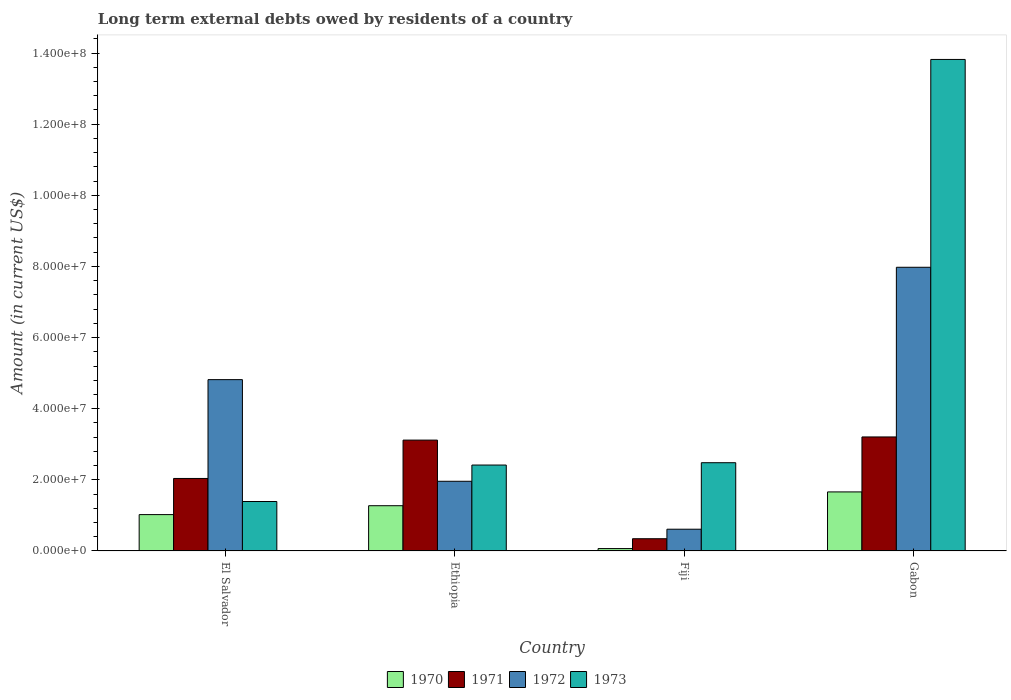How many different coloured bars are there?
Your response must be concise. 4. How many groups of bars are there?
Offer a very short reply. 4. Are the number of bars per tick equal to the number of legend labels?
Give a very brief answer. Yes. What is the label of the 1st group of bars from the left?
Provide a short and direct response. El Salvador. What is the amount of long-term external debts owed by residents in 1973 in El Salvador?
Provide a succinct answer. 1.39e+07. Across all countries, what is the maximum amount of long-term external debts owed by residents in 1973?
Make the answer very short. 1.38e+08. Across all countries, what is the minimum amount of long-term external debts owed by residents in 1972?
Provide a succinct answer. 6.12e+06. In which country was the amount of long-term external debts owed by residents in 1972 maximum?
Offer a terse response. Gabon. In which country was the amount of long-term external debts owed by residents in 1972 minimum?
Your answer should be compact. Fiji. What is the total amount of long-term external debts owed by residents in 1970 in the graph?
Offer a very short reply. 4.02e+07. What is the difference between the amount of long-term external debts owed by residents in 1973 in El Salvador and that in Fiji?
Give a very brief answer. -1.09e+07. What is the difference between the amount of long-term external debts owed by residents in 1971 in El Salvador and the amount of long-term external debts owed by residents in 1970 in Fiji?
Your answer should be very brief. 1.97e+07. What is the average amount of long-term external debts owed by residents in 1971 per country?
Make the answer very short. 2.18e+07. What is the difference between the amount of long-term external debts owed by residents of/in 1973 and amount of long-term external debts owed by residents of/in 1972 in Ethiopia?
Your answer should be compact. 4.56e+06. What is the ratio of the amount of long-term external debts owed by residents in 1970 in El Salvador to that in Fiji?
Offer a terse response. 15.1. Is the difference between the amount of long-term external debts owed by residents in 1973 in Fiji and Gabon greater than the difference between the amount of long-term external debts owed by residents in 1972 in Fiji and Gabon?
Keep it short and to the point. No. What is the difference between the highest and the second highest amount of long-term external debts owed by residents in 1971?
Make the answer very short. 8.88e+05. What is the difference between the highest and the lowest amount of long-term external debts owed by residents in 1971?
Provide a succinct answer. 2.86e+07. Is the sum of the amount of long-term external debts owed by residents in 1973 in Ethiopia and Fiji greater than the maximum amount of long-term external debts owed by residents in 1970 across all countries?
Ensure brevity in your answer.  Yes. What does the 3rd bar from the right in Gabon represents?
Keep it short and to the point. 1971. How many bars are there?
Ensure brevity in your answer.  16. Are all the bars in the graph horizontal?
Offer a very short reply. No. What is the difference between two consecutive major ticks on the Y-axis?
Make the answer very short. 2.00e+07. Does the graph contain any zero values?
Your answer should be very brief. No. Where does the legend appear in the graph?
Make the answer very short. Bottom center. How are the legend labels stacked?
Your answer should be compact. Horizontal. What is the title of the graph?
Your response must be concise. Long term external debts owed by residents of a country. Does "1993" appear as one of the legend labels in the graph?
Give a very brief answer. No. What is the Amount (in current US$) of 1970 in El Salvador?
Your answer should be very brief. 1.02e+07. What is the Amount (in current US$) of 1971 in El Salvador?
Give a very brief answer. 2.04e+07. What is the Amount (in current US$) of 1972 in El Salvador?
Provide a short and direct response. 4.82e+07. What is the Amount (in current US$) in 1973 in El Salvador?
Your answer should be very brief. 1.39e+07. What is the Amount (in current US$) in 1970 in Ethiopia?
Your answer should be very brief. 1.27e+07. What is the Amount (in current US$) of 1971 in Ethiopia?
Offer a terse response. 3.12e+07. What is the Amount (in current US$) of 1972 in Ethiopia?
Your answer should be very brief. 1.96e+07. What is the Amount (in current US$) in 1973 in Ethiopia?
Offer a very short reply. 2.42e+07. What is the Amount (in current US$) of 1970 in Fiji?
Provide a short and direct response. 6.77e+05. What is the Amount (in current US$) in 1971 in Fiji?
Provide a succinct answer. 3.45e+06. What is the Amount (in current US$) of 1972 in Fiji?
Your answer should be very brief. 6.12e+06. What is the Amount (in current US$) in 1973 in Fiji?
Make the answer very short. 2.48e+07. What is the Amount (in current US$) in 1970 in Gabon?
Provide a short and direct response. 1.66e+07. What is the Amount (in current US$) in 1971 in Gabon?
Keep it short and to the point. 3.21e+07. What is the Amount (in current US$) of 1972 in Gabon?
Give a very brief answer. 7.98e+07. What is the Amount (in current US$) in 1973 in Gabon?
Keep it short and to the point. 1.38e+08. Across all countries, what is the maximum Amount (in current US$) of 1970?
Keep it short and to the point. 1.66e+07. Across all countries, what is the maximum Amount (in current US$) of 1971?
Give a very brief answer. 3.21e+07. Across all countries, what is the maximum Amount (in current US$) in 1972?
Provide a short and direct response. 7.98e+07. Across all countries, what is the maximum Amount (in current US$) in 1973?
Ensure brevity in your answer.  1.38e+08. Across all countries, what is the minimum Amount (in current US$) in 1970?
Keep it short and to the point. 6.77e+05. Across all countries, what is the minimum Amount (in current US$) in 1971?
Your answer should be compact. 3.45e+06. Across all countries, what is the minimum Amount (in current US$) in 1972?
Ensure brevity in your answer.  6.12e+06. Across all countries, what is the minimum Amount (in current US$) of 1973?
Offer a terse response. 1.39e+07. What is the total Amount (in current US$) in 1970 in the graph?
Give a very brief answer. 4.02e+07. What is the total Amount (in current US$) in 1971 in the graph?
Your response must be concise. 8.71e+07. What is the total Amount (in current US$) of 1972 in the graph?
Make the answer very short. 1.54e+08. What is the total Amount (in current US$) of 1973 in the graph?
Ensure brevity in your answer.  2.01e+08. What is the difference between the Amount (in current US$) in 1970 in El Salvador and that in Ethiopia?
Your answer should be very brief. -2.50e+06. What is the difference between the Amount (in current US$) in 1971 in El Salvador and that in Ethiopia?
Offer a very short reply. -1.08e+07. What is the difference between the Amount (in current US$) of 1972 in El Salvador and that in Ethiopia?
Your response must be concise. 2.86e+07. What is the difference between the Amount (in current US$) in 1973 in El Salvador and that in Ethiopia?
Your answer should be compact. -1.03e+07. What is the difference between the Amount (in current US$) in 1970 in El Salvador and that in Fiji?
Give a very brief answer. 9.55e+06. What is the difference between the Amount (in current US$) in 1971 in El Salvador and that in Fiji?
Make the answer very short. 1.69e+07. What is the difference between the Amount (in current US$) of 1972 in El Salvador and that in Fiji?
Offer a terse response. 4.21e+07. What is the difference between the Amount (in current US$) in 1973 in El Salvador and that in Fiji?
Offer a very short reply. -1.09e+07. What is the difference between the Amount (in current US$) of 1970 in El Salvador and that in Gabon?
Your response must be concise. -6.38e+06. What is the difference between the Amount (in current US$) in 1971 in El Salvador and that in Gabon?
Provide a succinct answer. -1.17e+07. What is the difference between the Amount (in current US$) of 1972 in El Salvador and that in Gabon?
Ensure brevity in your answer.  -3.16e+07. What is the difference between the Amount (in current US$) in 1973 in El Salvador and that in Gabon?
Give a very brief answer. -1.24e+08. What is the difference between the Amount (in current US$) in 1970 in Ethiopia and that in Fiji?
Give a very brief answer. 1.20e+07. What is the difference between the Amount (in current US$) of 1971 in Ethiopia and that in Fiji?
Your answer should be compact. 2.77e+07. What is the difference between the Amount (in current US$) of 1972 in Ethiopia and that in Fiji?
Provide a succinct answer. 1.35e+07. What is the difference between the Amount (in current US$) of 1973 in Ethiopia and that in Fiji?
Give a very brief answer. -6.56e+05. What is the difference between the Amount (in current US$) of 1970 in Ethiopia and that in Gabon?
Keep it short and to the point. -3.88e+06. What is the difference between the Amount (in current US$) in 1971 in Ethiopia and that in Gabon?
Your answer should be compact. -8.88e+05. What is the difference between the Amount (in current US$) in 1972 in Ethiopia and that in Gabon?
Your response must be concise. -6.02e+07. What is the difference between the Amount (in current US$) in 1973 in Ethiopia and that in Gabon?
Provide a short and direct response. -1.14e+08. What is the difference between the Amount (in current US$) of 1970 in Fiji and that in Gabon?
Offer a terse response. -1.59e+07. What is the difference between the Amount (in current US$) in 1971 in Fiji and that in Gabon?
Your answer should be very brief. -2.86e+07. What is the difference between the Amount (in current US$) in 1972 in Fiji and that in Gabon?
Make the answer very short. -7.36e+07. What is the difference between the Amount (in current US$) in 1973 in Fiji and that in Gabon?
Provide a succinct answer. -1.13e+08. What is the difference between the Amount (in current US$) of 1970 in El Salvador and the Amount (in current US$) of 1971 in Ethiopia?
Your response must be concise. -2.09e+07. What is the difference between the Amount (in current US$) of 1970 in El Salvador and the Amount (in current US$) of 1972 in Ethiopia?
Keep it short and to the point. -9.37e+06. What is the difference between the Amount (in current US$) of 1970 in El Salvador and the Amount (in current US$) of 1973 in Ethiopia?
Offer a terse response. -1.39e+07. What is the difference between the Amount (in current US$) in 1971 in El Salvador and the Amount (in current US$) in 1972 in Ethiopia?
Make the answer very short. 7.91e+05. What is the difference between the Amount (in current US$) in 1971 in El Salvador and the Amount (in current US$) in 1973 in Ethiopia?
Your answer should be compact. -3.77e+06. What is the difference between the Amount (in current US$) of 1972 in El Salvador and the Amount (in current US$) of 1973 in Ethiopia?
Keep it short and to the point. 2.40e+07. What is the difference between the Amount (in current US$) in 1970 in El Salvador and the Amount (in current US$) in 1971 in Fiji?
Keep it short and to the point. 6.78e+06. What is the difference between the Amount (in current US$) of 1970 in El Salvador and the Amount (in current US$) of 1972 in Fiji?
Offer a very short reply. 4.10e+06. What is the difference between the Amount (in current US$) of 1970 in El Salvador and the Amount (in current US$) of 1973 in Fiji?
Your answer should be very brief. -1.46e+07. What is the difference between the Amount (in current US$) of 1971 in El Salvador and the Amount (in current US$) of 1972 in Fiji?
Your answer should be compact. 1.43e+07. What is the difference between the Amount (in current US$) in 1971 in El Salvador and the Amount (in current US$) in 1973 in Fiji?
Your answer should be compact. -4.43e+06. What is the difference between the Amount (in current US$) of 1972 in El Salvador and the Amount (in current US$) of 1973 in Fiji?
Provide a short and direct response. 2.34e+07. What is the difference between the Amount (in current US$) in 1970 in El Salvador and the Amount (in current US$) in 1971 in Gabon?
Ensure brevity in your answer.  -2.18e+07. What is the difference between the Amount (in current US$) of 1970 in El Salvador and the Amount (in current US$) of 1972 in Gabon?
Ensure brevity in your answer.  -6.95e+07. What is the difference between the Amount (in current US$) in 1970 in El Salvador and the Amount (in current US$) in 1973 in Gabon?
Your answer should be compact. -1.28e+08. What is the difference between the Amount (in current US$) of 1971 in El Salvador and the Amount (in current US$) of 1972 in Gabon?
Your answer should be very brief. -5.94e+07. What is the difference between the Amount (in current US$) in 1971 in El Salvador and the Amount (in current US$) in 1973 in Gabon?
Make the answer very short. -1.18e+08. What is the difference between the Amount (in current US$) of 1972 in El Salvador and the Amount (in current US$) of 1973 in Gabon?
Your response must be concise. -9.00e+07. What is the difference between the Amount (in current US$) in 1970 in Ethiopia and the Amount (in current US$) in 1971 in Fiji?
Offer a very short reply. 9.28e+06. What is the difference between the Amount (in current US$) in 1970 in Ethiopia and the Amount (in current US$) in 1972 in Fiji?
Offer a very short reply. 6.61e+06. What is the difference between the Amount (in current US$) in 1970 in Ethiopia and the Amount (in current US$) in 1973 in Fiji?
Give a very brief answer. -1.21e+07. What is the difference between the Amount (in current US$) in 1971 in Ethiopia and the Amount (in current US$) in 1972 in Fiji?
Your answer should be very brief. 2.51e+07. What is the difference between the Amount (in current US$) of 1971 in Ethiopia and the Amount (in current US$) of 1973 in Fiji?
Your answer should be very brief. 6.36e+06. What is the difference between the Amount (in current US$) in 1972 in Ethiopia and the Amount (in current US$) in 1973 in Fiji?
Keep it short and to the point. -5.22e+06. What is the difference between the Amount (in current US$) of 1970 in Ethiopia and the Amount (in current US$) of 1971 in Gabon?
Offer a terse response. -1.93e+07. What is the difference between the Amount (in current US$) of 1970 in Ethiopia and the Amount (in current US$) of 1972 in Gabon?
Offer a very short reply. -6.70e+07. What is the difference between the Amount (in current US$) of 1970 in Ethiopia and the Amount (in current US$) of 1973 in Gabon?
Your response must be concise. -1.25e+08. What is the difference between the Amount (in current US$) in 1971 in Ethiopia and the Amount (in current US$) in 1972 in Gabon?
Give a very brief answer. -4.86e+07. What is the difference between the Amount (in current US$) in 1971 in Ethiopia and the Amount (in current US$) in 1973 in Gabon?
Keep it short and to the point. -1.07e+08. What is the difference between the Amount (in current US$) in 1972 in Ethiopia and the Amount (in current US$) in 1973 in Gabon?
Keep it short and to the point. -1.19e+08. What is the difference between the Amount (in current US$) of 1970 in Fiji and the Amount (in current US$) of 1971 in Gabon?
Give a very brief answer. -3.14e+07. What is the difference between the Amount (in current US$) of 1970 in Fiji and the Amount (in current US$) of 1972 in Gabon?
Your response must be concise. -7.91e+07. What is the difference between the Amount (in current US$) in 1970 in Fiji and the Amount (in current US$) in 1973 in Gabon?
Your answer should be compact. -1.38e+08. What is the difference between the Amount (in current US$) of 1971 in Fiji and the Amount (in current US$) of 1972 in Gabon?
Ensure brevity in your answer.  -7.63e+07. What is the difference between the Amount (in current US$) in 1971 in Fiji and the Amount (in current US$) in 1973 in Gabon?
Ensure brevity in your answer.  -1.35e+08. What is the difference between the Amount (in current US$) of 1972 in Fiji and the Amount (in current US$) of 1973 in Gabon?
Keep it short and to the point. -1.32e+08. What is the average Amount (in current US$) of 1970 per country?
Provide a short and direct response. 1.01e+07. What is the average Amount (in current US$) of 1971 per country?
Ensure brevity in your answer.  2.18e+07. What is the average Amount (in current US$) of 1972 per country?
Offer a terse response. 3.84e+07. What is the average Amount (in current US$) of 1973 per country?
Provide a succinct answer. 5.03e+07. What is the difference between the Amount (in current US$) in 1970 and Amount (in current US$) in 1971 in El Salvador?
Offer a terse response. -1.02e+07. What is the difference between the Amount (in current US$) in 1970 and Amount (in current US$) in 1972 in El Salvador?
Offer a terse response. -3.79e+07. What is the difference between the Amount (in current US$) of 1970 and Amount (in current US$) of 1973 in El Salvador?
Give a very brief answer. -3.68e+06. What is the difference between the Amount (in current US$) of 1971 and Amount (in current US$) of 1972 in El Salvador?
Ensure brevity in your answer.  -2.78e+07. What is the difference between the Amount (in current US$) of 1971 and Amount (in current US$) of 1973 in El Salvador?
Provide a short and direct response. 6.48e+06. What is the difference between the Amount (in current US$) of 1972 and Amount (in current US$) of 1973 in El Salvador?
Provide a succinct answer. 3.43e+07. What is the difference between the Amount (in current US$) in 1970 and Amount (in current US$) in 1971 in Ethiopia?
Ensure brevity in your answer.  -1.84e+07. What is the difference between the Amount (in current US$) in 1970 and Amount (in current US$) in 1972 in Ethiopia?
Make the answer very short. -6.87e+06. What is the difference between the Amount (in current US$) in 1970 and Amount (in current US$) in 1973 in Ethiopia?
Keep it short and to the point. -1.14e+07. What is the difference between the Amount (in current US$) in 1971 and Amount (in current US$) in 1972 in Ethiopia?
Offer a terse response. 1.16e+07. What is the difference between the Amount (in current US$) of 1971 and Amount (in current US$) of 1973 in Ethiopia?
Your answer should be compact. 7.01e+06. What is the difference between the Amount (in current US$) of 1972 and Amount (in current US$) of 1973 in Ethiopia?
Your answer should be very brief. -4.56e+06. What is the difference between the Amount (in current US$) in 1970 and Amount (in current US$) in 1971 in Fiji?
Your response must be concise. -2.77e+06. What is the difference between the Amount (in current US$) of 1970 and Amount (in current US$) of 1972 in Fiji?
Ensure brevity in your answer.  -5.44e+06. What is the difference between the Amount (in current US$) of 1970 and Amount (in current US$) of 1973 in Fiji?
Provide a succinct answer. -2.41e+07. What is the difference between the Amount (in current US$) of 1971 and Amount (in current US$) of 1972 in Fiji?
Keep it short and to the point. -2.68e+06. What is the difference between the Amount (in current US$) of 1971 and Amount (in current US$) of 1973 in Fiji?
Offer a very short reply. -2.14e+07. What is the difference between the Amount (in current US$) in 1972 and Amount (in current US$) in 1973 in Fiji?
Provide a succinct answer. -1.87e+07. What is the difference between the Amount (in current US$) of 1970 and Amount (in current US$) of 1971 in Gabon?
Give a very brief answer. -1.55e+07. What is the difference between the Amount (in current US$) of 1970 and Amount (in current US$) of 1972 in Gabon?
Provide a short and direct response. -6.32e+07. What is the difference between the Amount (in current US$) in 1970 and Amount (in current US$) in 1973 in Gabon?
Your answer should be compact. -1.22e+08. What is the difference between the Amount (in current US$) of 1971 and Amount (in current US$) of 1972 in Gabon?
Give a very brief answer. -4.77e+07. What is the difference between the Amount (in current US$) of 1971 and Amount (in current US$) of 1973 in Gabon?
Provide a succinct answer. -1.06e+08. What is the difference between the Amount (in current US$) in 1972 and Amount (in current US$) in 1973 in Gabon?
Give a very brief answer. -5.84e+07. What is the ratio of the Amount (in current US$) in 1970 in El Salvador to that in Ethiopia?
Your answer should be compact. 0.8. What is the ratio of the Amount (in current US$) in 1971 in El Salvador to that in Ethiopia?
Offer a very short reply. 0.65. What is the ratio of the Amount (in current US$) in 1972 in El Salvador to that in Ethiopia?
Offer a very short reply. 2.46. What is the ratio of the Amount (in current US$) of 1973 in El Salvador to that in Ethiopia?
Offer a terse response. 0.58. What is the ratio of the Amount (in current US$) of 1970 in El Salvador to that in Fiji?
Offer a terse response. 15.1. What is the ratio of the Amount (in current US$) of 1971 in El Salvador to that in Fiji?
Make the answer very short. 5.92. What is the ratio of the Amount (in current US$) in 1972 in El Salvador to that in Fiji?
Ensure brevity in your answer.  7.87. What is the ratio of the Amount (in current US$) of 1973 in El Salvador to that in Fiji?
Provide a short and direct response. 0.56. What is the ratio of the Amount (in current US$) of 1970 in El Salvador to that in Gabon?
Offer a very short reply. 0.62. What is the ratio of the Amount (in current US$) in 1971 in El Salvador to that in Gabon?
Keep it short and to the point. 0.64. What is the ratio of the Amount (in current US$) in 1972 in El Salvador to that in Gabon?
Give a very brief answer. 0.6. What is the ratio of the Amount (in current US$) in 1973 in El Salvador to that in Gabon?
Give a very brief answer. 0.1. What is the ratio of the Amount (in current US$) of 1970 in Ethiopia to that in Fiji?
Give a very brief answer. 18.8. What is the ratio of the Amount (in current US$) of 1971 in Ethiopia to that in Fiji?
Provide a succinct answer. 9.05. What is the ratio of the Amount (in current US$) in 1972 in Ethiopia to that in Fiji?
Your response must be concise. 3.2. What is the ratio of the Amount (in current US$) of 1973 in Ethiopia to that in Fiji?
Keep it short and to the point. 0.97. What is the ratio of the Amount (in current US$) in 1970 in Ethiopia to that in Gabon?
Your answer should be very brief. 0.77. What is the ratio of the Amount (in current US$) of 1971 in Ethiopia to that in Gabon?
Ensure brevity in your answer.  0.97. What is the ratio of the Amount (in current US$) of 1972 in Ethiopia to that in Gabon?
Provide a short and direct response. 0.25. What is the ratio of the Amount (in current US$) of 1973 in Ethiopia to that in Gabon?
Make the answer very short. 0.17. What is the ratio of the Amount (in current US$) of 1970 in Fiji to that in Gabon?
Offer a terse response. 0.04. What is the ratio of the Amount (in current US$) of 1971 in Fiji to that in Gabon?
Offer a terse response. 0.11. What is the ratio of the Amount (in current US$) in 1972 in Fiji to that in Gabon?
Offer a very short reply. 0.08. What is the ratio of the Amount (in current US$) in 1973 in Fiji to that in Gabon?
Make the answer very short. 0.18. What is the difference between the highest and the second highest Amount (in current US$) of 1970?
Your answer should be compact. 3.88e+06. What is the difference between the highest and the second highest Amount (in current US$) in 1971?
Provide a succinct answer. 8.88e+05. What is the difference between the highest and the second highest Amount (in current US$) of 1972?
Provide a short and direct response. 3.16e+07. What is the difference between the highest and the second highest Amount (in current US$) of 1973?
Give a very brief answer. 1.13e+08. What is the difference between the highest and the lowest Amount (in current US$) in 1970?
Make the answer very short. 1.59e+07. What is the difference between the highest and the lowest Amount (in current US$) of 1971?
Your answer should be compact. 2.86e+07. What is the difference between the highest and the lowest Amount (in current US$) in 1972?
Keep it short and to the point. 7.36e+07. What is the difference between the highest and the lowest Amount (in current US$) of 1973?
Provide a short and direct response. 1.24e+08. 